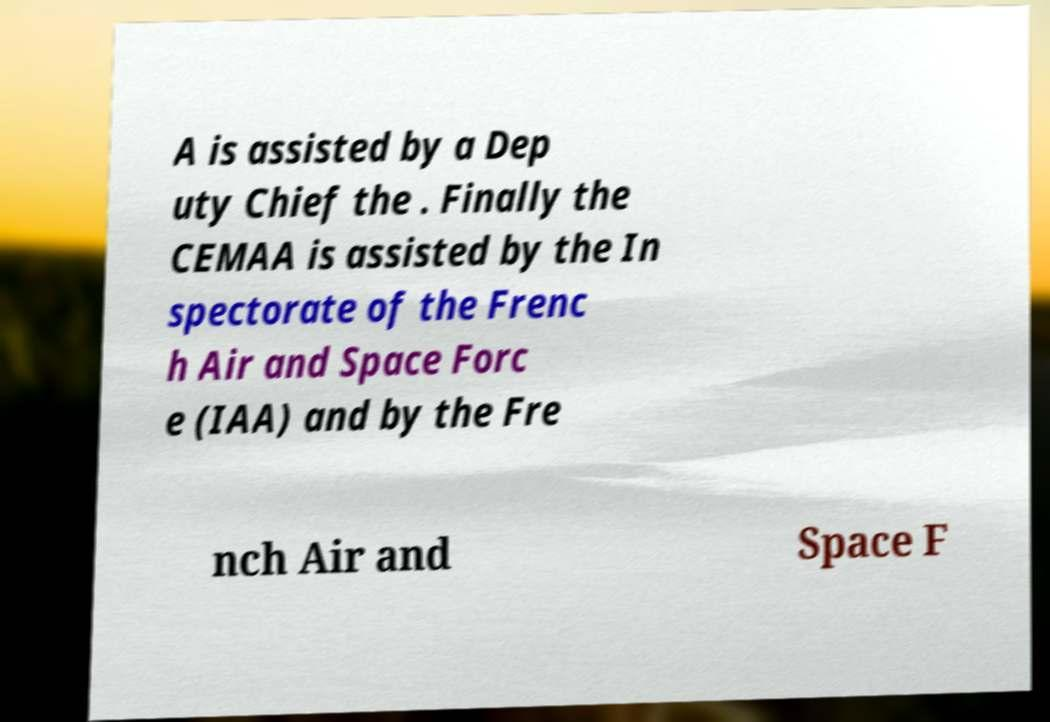Please identify and transcribe the text found in this image. A is assisted by a Dep uty Chief the . Finally the CEMAA is assisted by the In spectorate of the Frenc h Air and Space Forc e (IAA) and by the Fre nch Air and Space F 